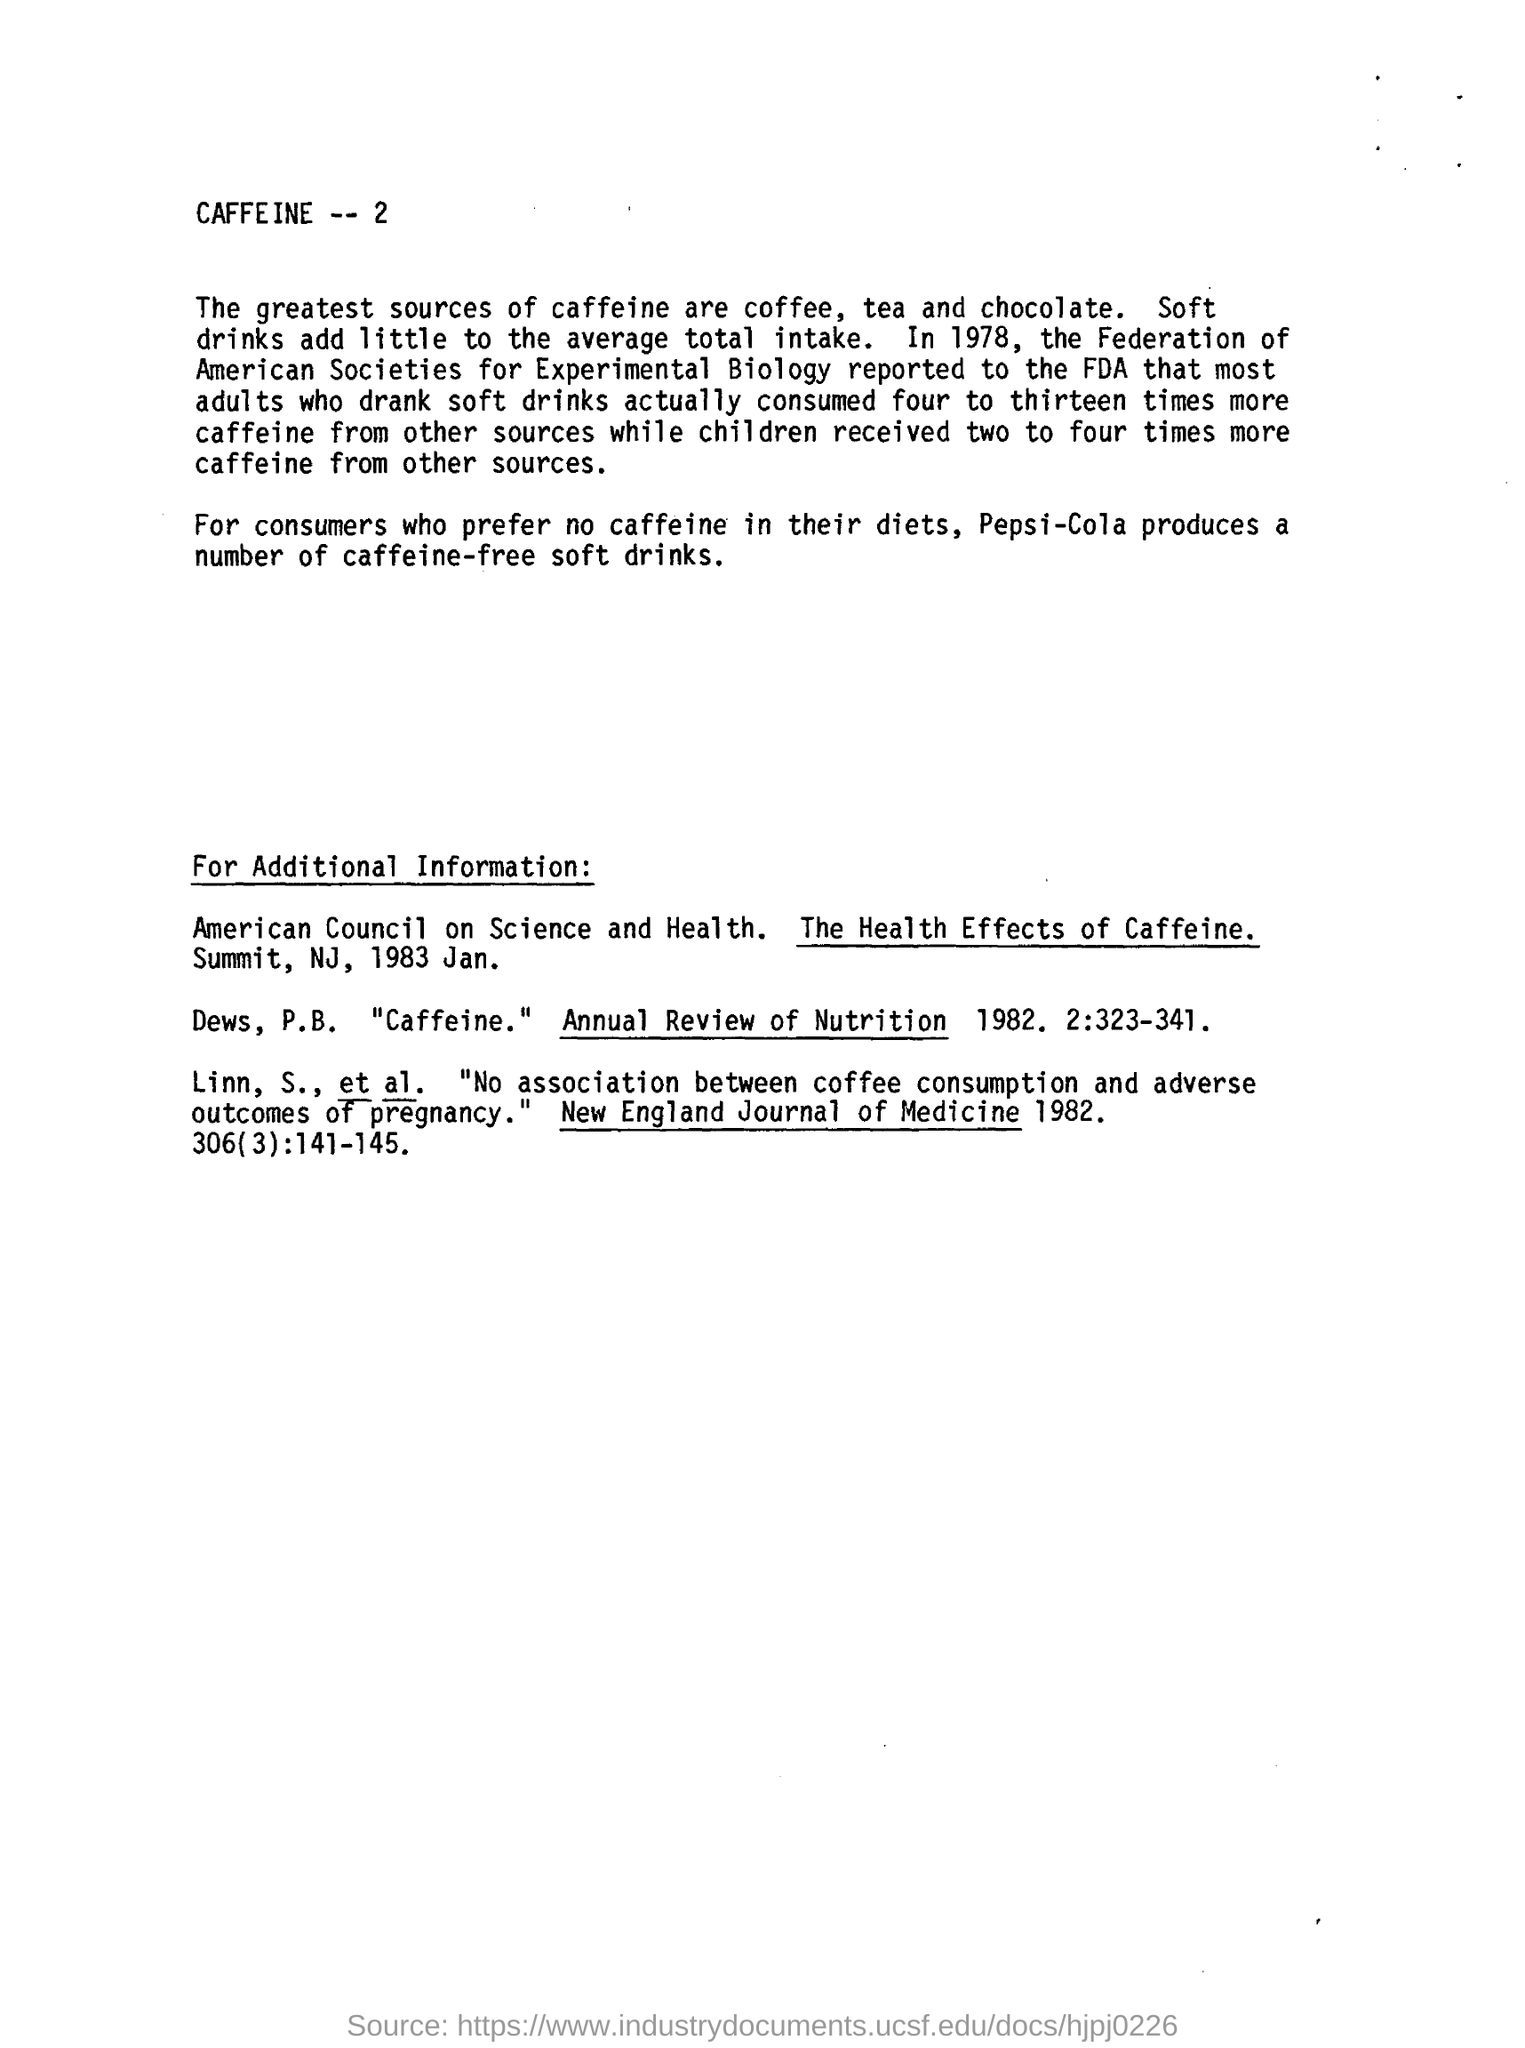What are the greatest sources of caffeine?
Give a very brief answer. Coffee, tea and chocolate. In which year did American Council on Science and Health , published "the health effects of caffeine"?
Keep it short and to the point. 1983. What add little to the average total intake of caffeine?
Provide a short and direct response. Soft drinks. What produces a number of caffeine free soft drink for those who prefer no caffeine in their diets?
Keep it short and to the point. Pepsi-cola. 